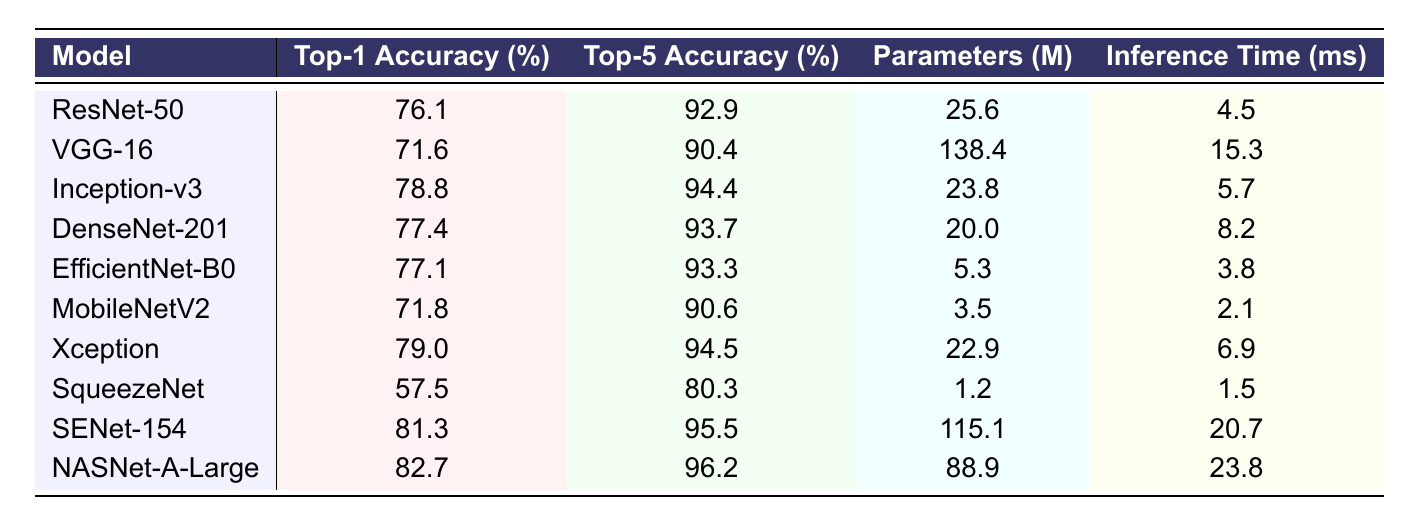What is the Top-1 Accuracy of the NASNet-A-Large model? The table shows the Top-1 Accuracy of NASNet-A-Large, which is 82.7%.
Answer: 82.7% Which model has the highest Top-5 Accuracy? Looking through the Top-5 Accuracy values, NASNet-A-Large has the highest value at 96.2%.
Answer: NASNet-A-Large How many parameters does the EfficientNet-B0 model have? The table lists that EfficientNet-B0 has 5.3 million parameters.
Answer: 5.3 million What is the difference in Top-1 Accuracy between SENet-154 and SqueezeNet? SENet-154 has a Top-1 Accuracy of 81.3%, and SqueezeNet has 57.5%. The difference is 81.3 - 57.5 = 23.8%.
Answer: 23.8% Which model has the fastest inference time? By comparing the inference times, MobileNetV2 has the fastest inference time at 2.1 ms.
Answer: MobileNetV2 What is the average Top-1 Accuracy of all models listed in the table? To find the average, add all Top-1 Accuracy values: (76.1 + 71.6 + 78.8 + 77.4 + 77.1 + 71.8 + 79.0 + 57.5 + 81.3 + 82.7) =  795.3. There are 10 models, so the average is 795.3 / 10 = 79.53%.
Answer: 79.53% True or False: The Inception-v3 model has more parameters than the DenseNet-201 model. Inception-v3 has 23.8 million parameters, whereas DenseNet-201 has 20 million. Thus, Inception-v3 has more parameters.
Answer: True Which model has the highest number of parameters and what is that value? From the table, VGG-16 has the highest number of parameters at 138.4 million.
Answer: 138.4 million If we combine the Top-1 Accuracy of ResNet-50 and DenseNet-201, what is the total? Adding the Top-1 Accuracies: ResNet-50 has 76.1%, and DenseNet-201 has 77.4%. The total is 76.1 + 77.4 = 153.5%.
Answer: 153.5% Which model has a Top-5 Accuracy less than 85%? By reviewing the Top-5 Accuracy values, SqueezeNet has a Top-5 Accuracy of 80.3%, which is less than 85%.
Answer: SqueezeNet What is the parameter count difference between SENet-154 and NASNet-A-Large? SENet-154 has 115.1 million parameters and NASNet-A-Large has 88.9 million. The difference is 115.1 - 88.9 = 26.2 million.
Answer: 26.2 million 